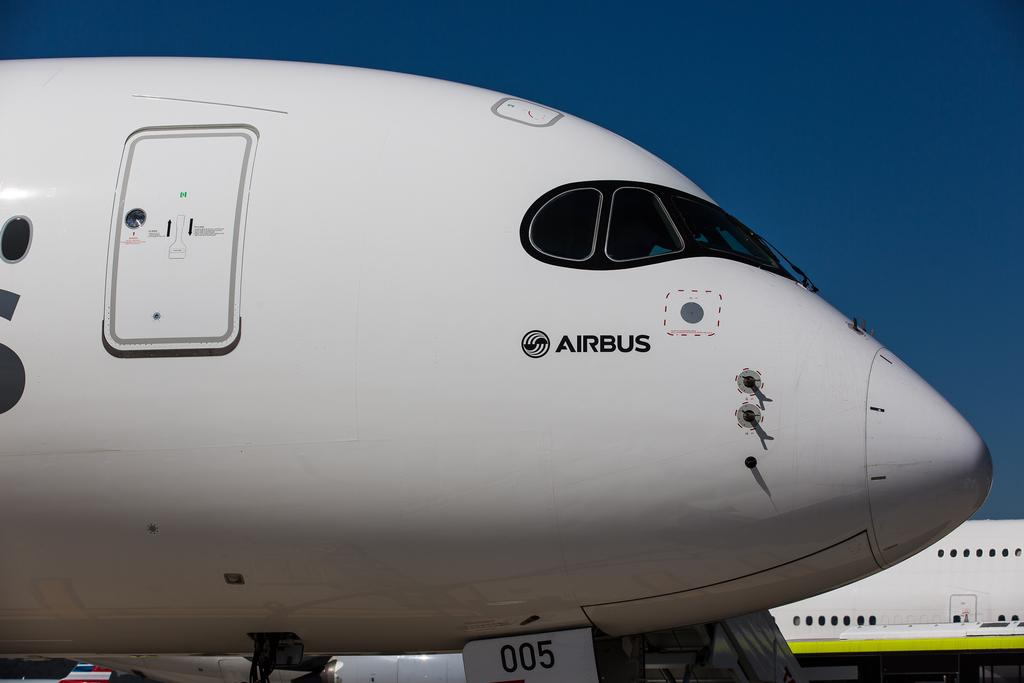<image>
Create a compact narrative representing the image presented. A large white Airbus is parked in an airport by another jet. 